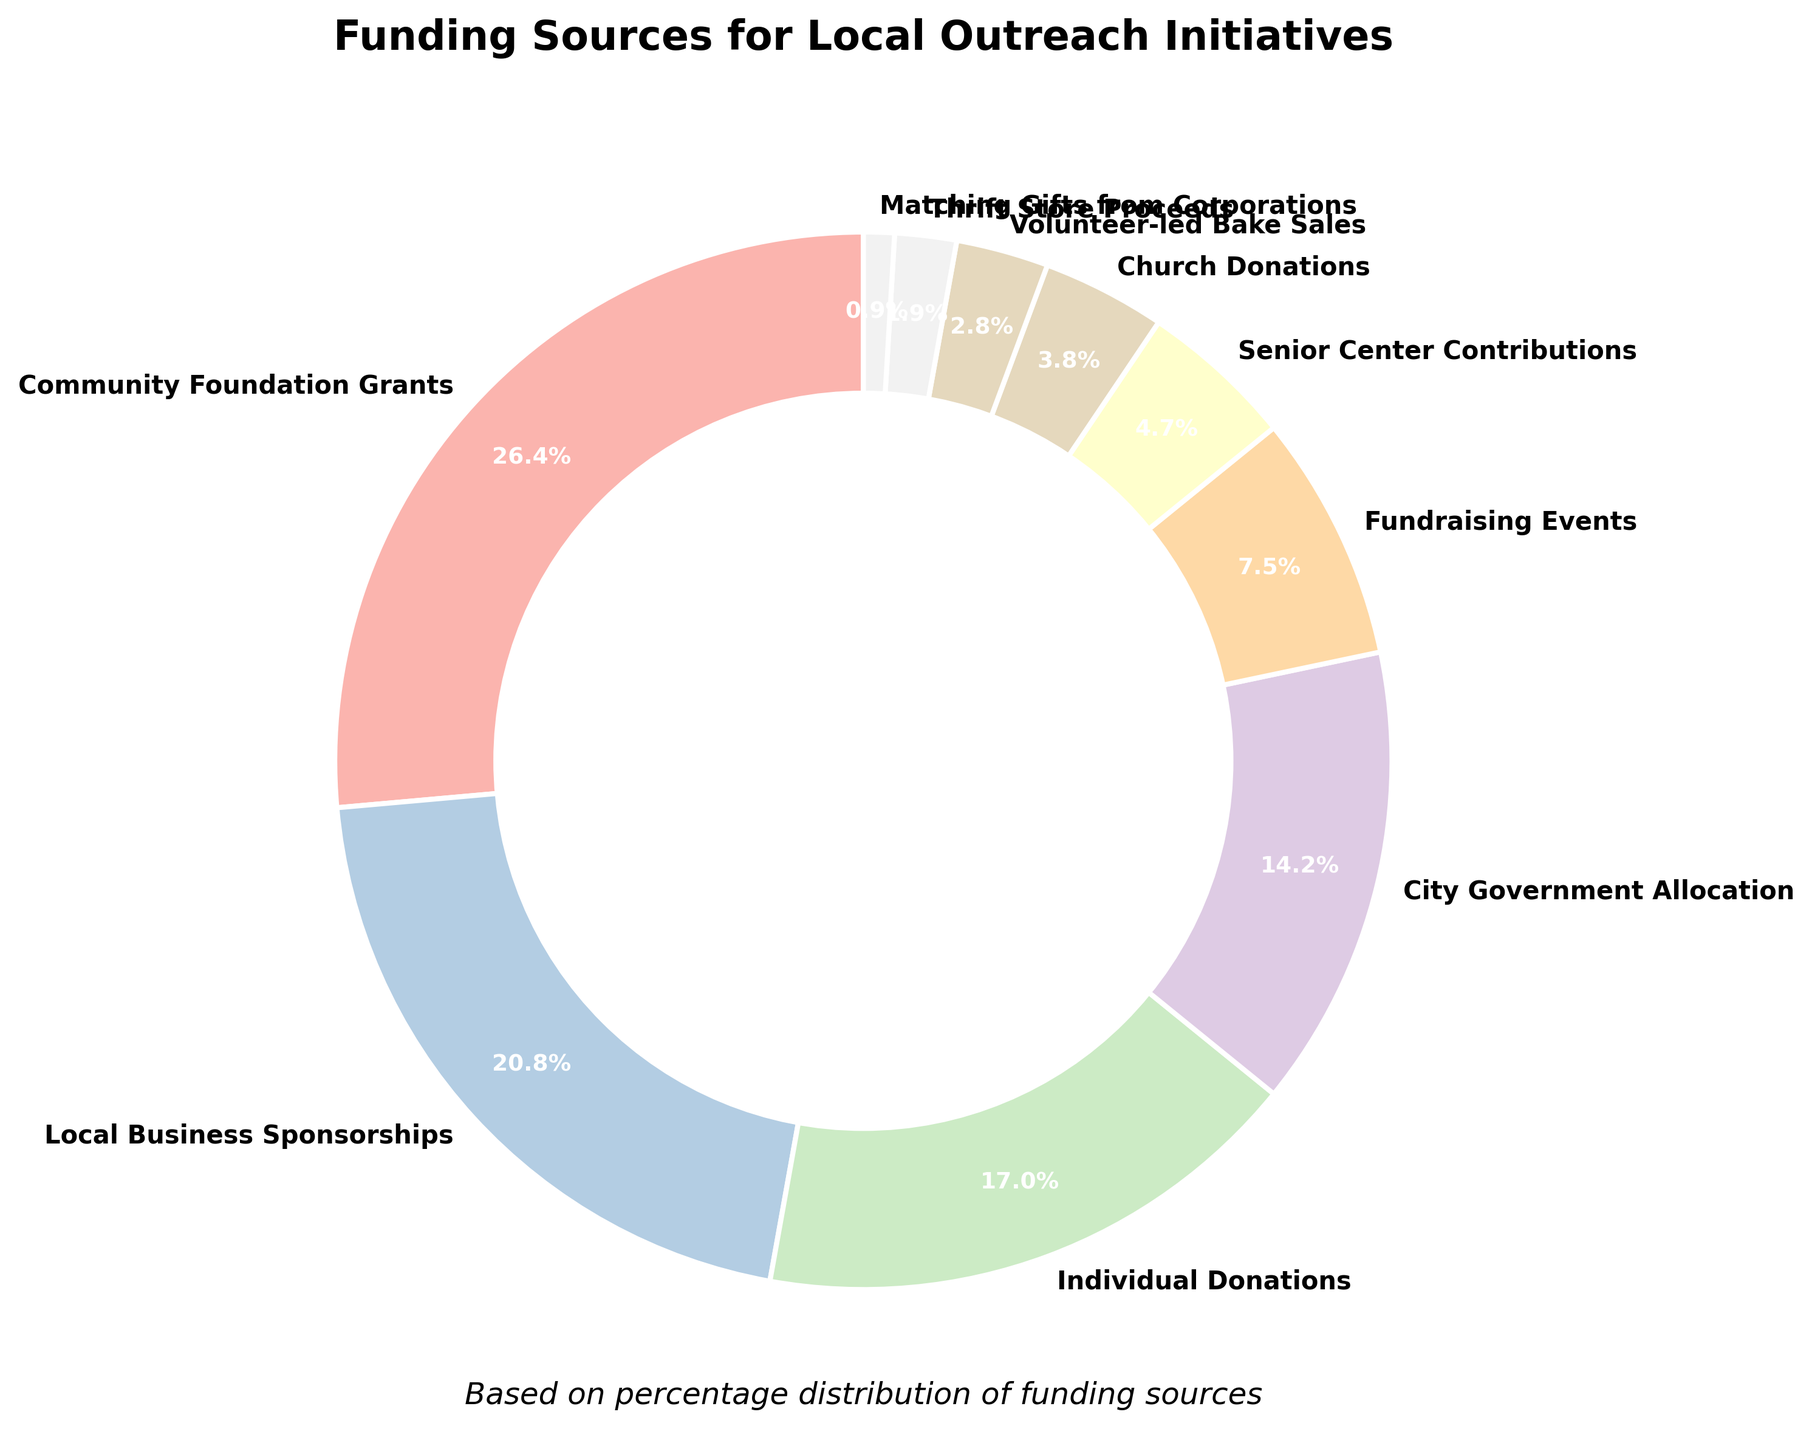What's the largest funding source represented on the pie chart? The largest portion of the pie chart is "Community Foundation Grants" with 28% of the funding.
Answer: Community Foundation Grants Which funding source contributes the smallest percentage to the outreach initiatives? The smallest slice on the pie chart is for "Matching Gifts from Corporations," contributing only 1%.
Answer: Matching Gifts from Corporations How much more does "Community Foundation Grants" contribute compared to "Local Business Sponsorships"? "Community Foundation Grants" contribute 28%, and "Local Business Sponsorships" contribute 22%. The difference is 28% - 22% = 6%.
Answer: 6% What is the combined percentage of "Fundraising Events" and "Senior Center Contributions"? "Fundraising Events" contribute 8% and "Senior Center Contributions" contribute 5%. Their combined total is 8% + 5% = 13%.
Answer: 13% How does the percentage of "Individual Donations" compare to "City Government Allocation"? "Individual Donations" contribute 18%, while "City Government Allocation" contributes 15%. Thus, Individual Donations contribute 3% more.
Answer: 3% If you combine the contributions from "Church Donations" and "Volunteer-led Bake Sales," what percentage do they form together? "Church Donations" and "Volunteer-led Bake Sales" form 4% + 3% = 7% together.
Answer: 7% Which funding sources contribute more than 20% individually? "Community Foundation Grants" at 28% and "Local Business Sponsorships" at 22% each contribute more than 20%.
Answer: Community Foundation Grants, Local Business Sponsorships What is the total percentage contributed by all funding sources involved in the pie chart? Add all the contributions: 28% + 22% + 18% + 15% + 8% + 5% + 4% + 3% + 2% + 1% = 106%. Since these percentages must sum to 100%, there must be an inconsistency in the data.
Answer: Inconsistent data 